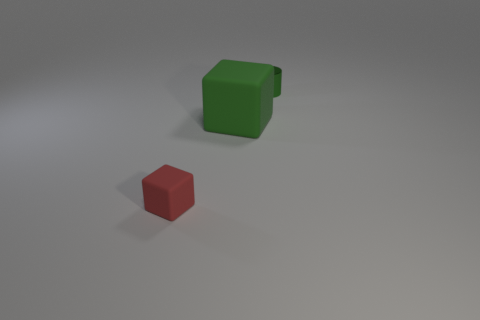How big is the rubber thing that is to the right of the tiny thing that is in front of the large rubber block?
Offer a terse response. Large. The other object that is the same shape as the large thing is what color?
Your response must be concise. Red. How big is the green matte block?
Make the answer very short. Large. How many cubes are either large rubber things or small green shiny objects?
Make the answer very short. 1. The other thing that is the same shape as the red rubber object is what size?
Provide a succinct answer. Large. What number of small red rubber objects are there?
Your answer should be compact. 1. Is the shape of the red object the same as the green thing that is behind the large matte cube?
Give a very brief answer. No. What size is the green object in front of the small cylinder?
Ensure brevity in your answer.  Large. What is the material of the tiny cylinder?
Ensure brevity in your answer.  Metal. There is a small thing in front of the tiny cylinder; is it the same shape as the big rubber thing?
Your answer should be compact. Yes. 